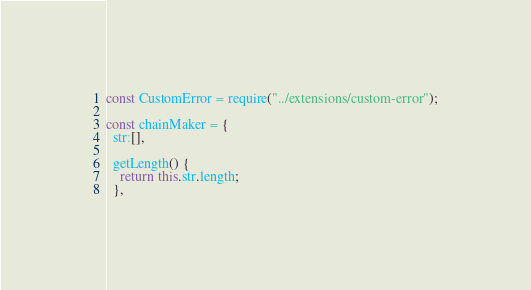<code> <loc_0><loc_0><loc_500><loc_500><_JavaScript_>const CustomError = require("../extensions/custom-error");

const chainMaker = {
  str:[],

  getLength() {
    return this.str.length;
  },</code> 